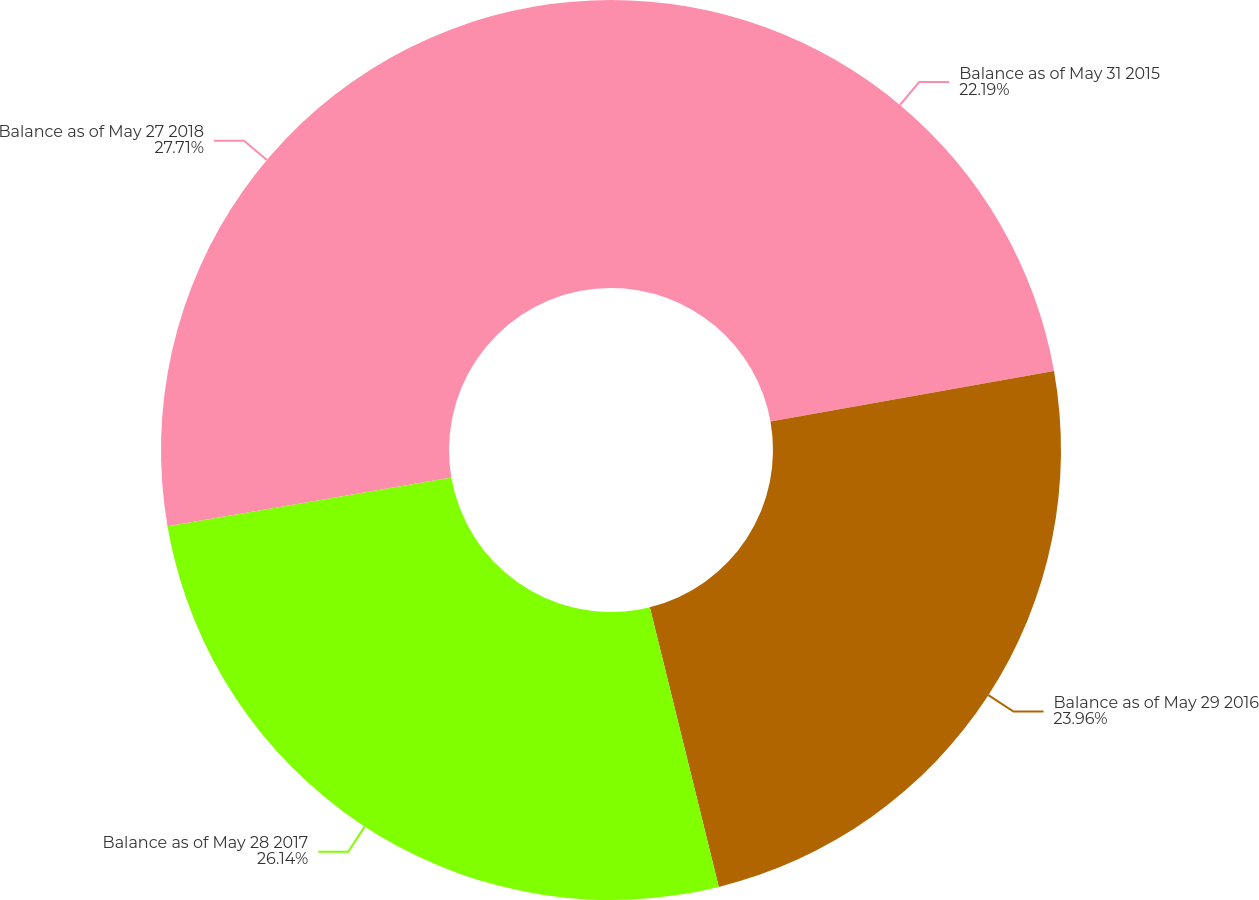Convert chart to OTSL. <chart><loc_0><loc_0><loc_500><loc_500><pie_chart><fcel>Balance as of May 31 2015<fcel>Balance as of May 29 2016<fcel>Balance as of May 28 2017<fcel>Balance as of May 27 2018<nl><fcel>22.19%<fcel>23.96%<fcel>26.14%<fcel>27.71%<nl></chart> 